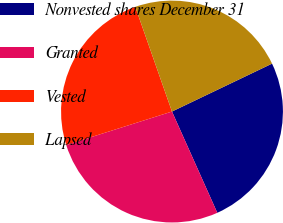Convert chart. <chart><loc_0><loc_0><loc_500><loc_500><pie_chart><fcel>Nonvested shares December 31<fcel>Granted<fcel>Vested<fcel>Lapsed<nl><fcel>25.41%<fcel>26.82%<fcel>24.51%<fcel>23.26%<nl></chart> 